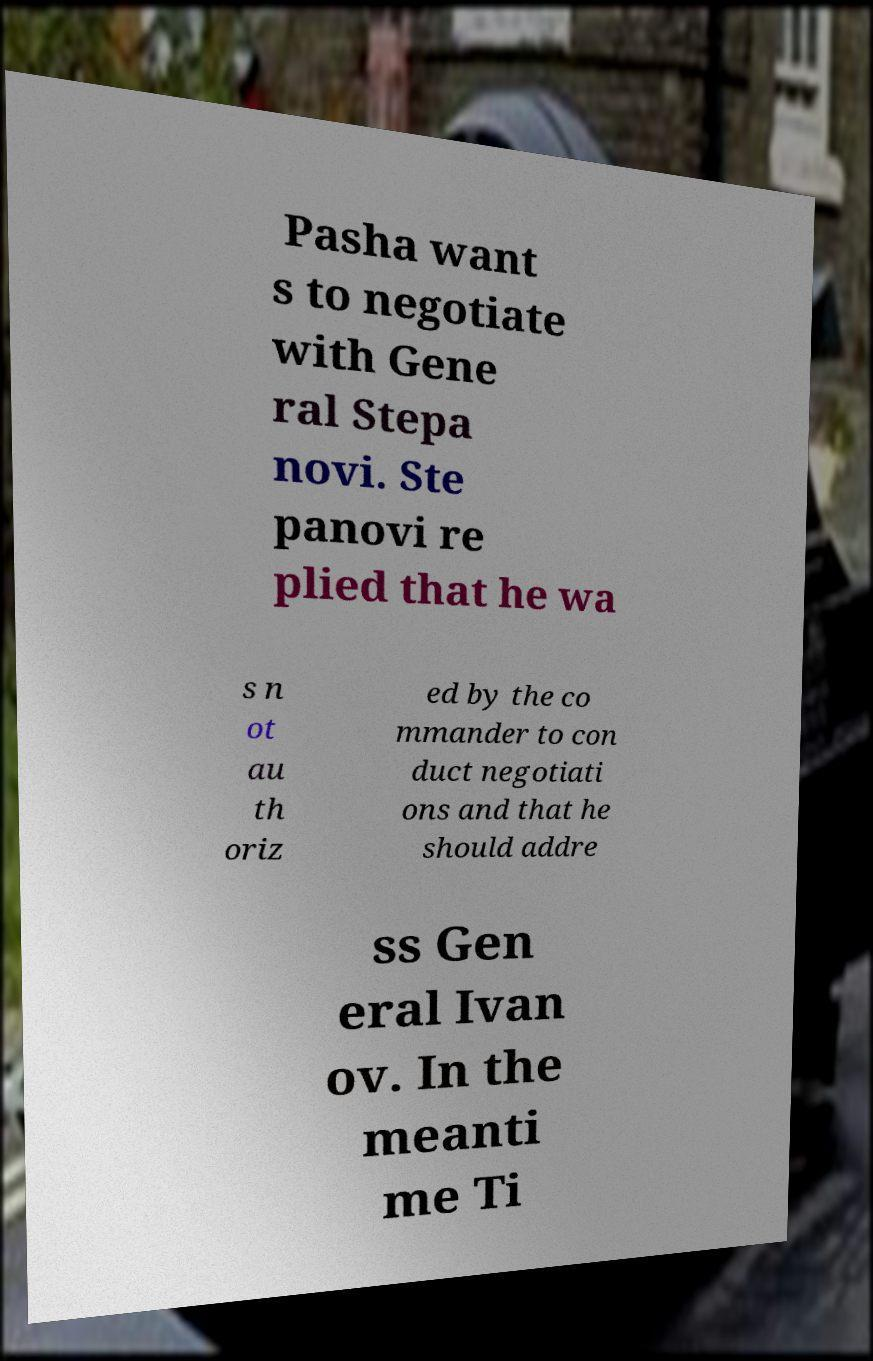Can you read and provide the text displayed in the image?This photo seems to have some interesting text. Can you extract and type it out for me? Pasha want s to negotiate with Gene ral Stepa novi. Ste panovi re plied that he wa s n ot au th oriz ed by the co mmander to con duct negotiati ons and that he should addre ss Gen eral Ivan ov. In the meanti me Ti 